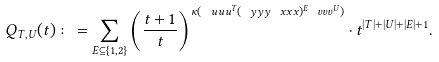<formula> <loc_0><loc_0><loc_500><loc_500>Q _ { T , U } ( t ) \colon = \sum _ { E \subseteq \{ 1 , 2 \} } \left ( \frac { t + 1 } { t } \right ) ^ { \kappa ( \ u u u ^ { T } ( \ y y y \ x x x ) ^ { E } \ v v v ^ { U } ) } \cdot t ^ { | T | + | U | + | E | + 1 } .</formula> 